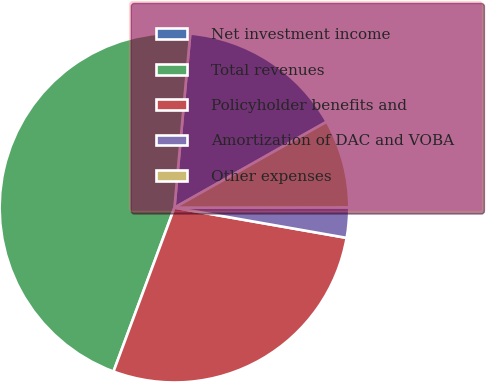Convert chart to OTSL. <chart><loc_0><loc_0><loc_500><loc_500><pie_chart><fcel>Net investment income<fcel>Total revenues<fcel>Policyholder benefits and<fcel>Amortization of DAC and VOBA<fcel>Other expenses<nl><fcel>15.38%<fcel>45.77%<fcel>27.9%<fcel>2.79%<fcel>8.15%<nl></chart> 